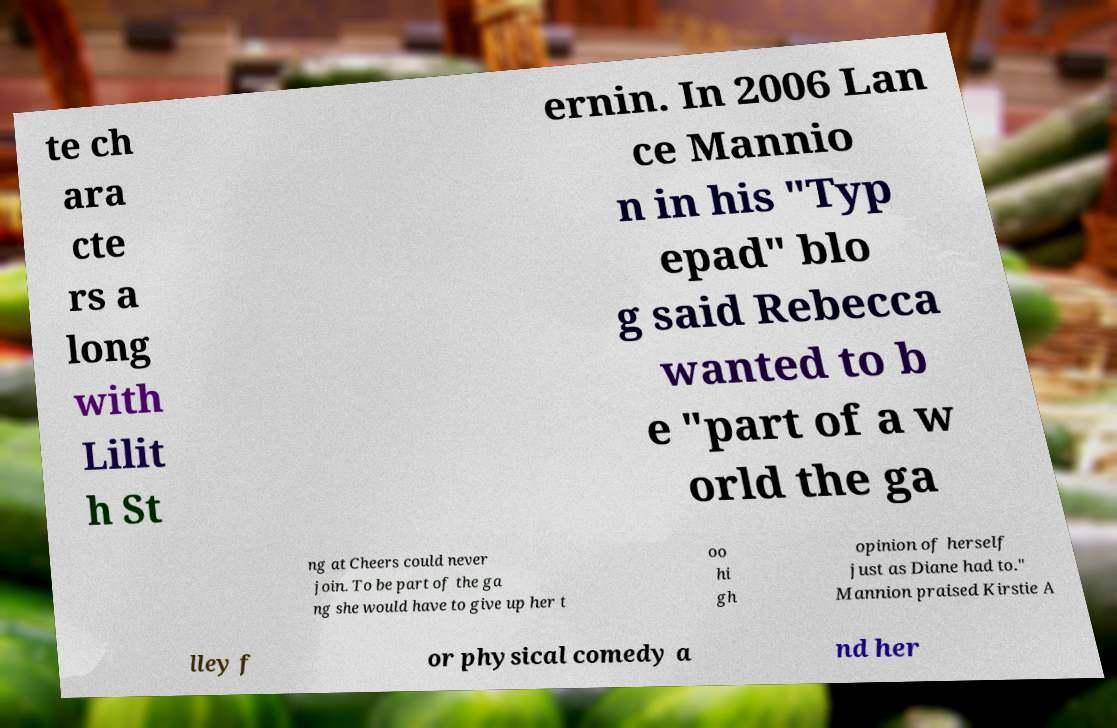Please identify and transcribe the text found in this image. te ch ara cte rs a long with Lilit h St ernin. In 2006 Lan ce Mannio n in his "Typ epad" blo g said Rebecca wanted to b e "part of a w orld the ga ng at Cheers could never join. To be part of the ga ng she would have to give up her t oo hi gh opinion of herself just as Diane had to." Mannion praised Kirstie A lley f or physical comedy a nd her 